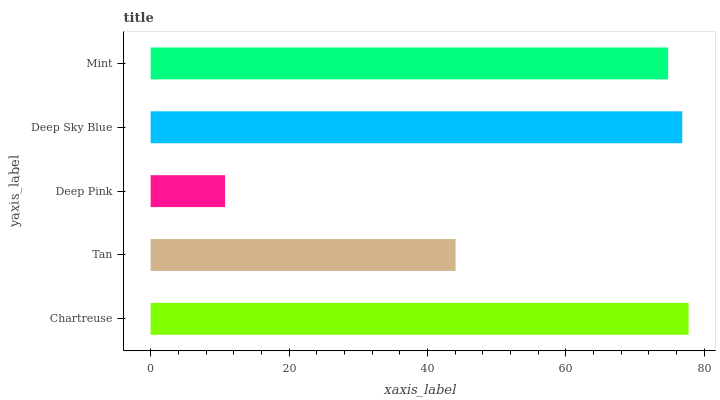Is Deep Pink the minimum?
Answer yes or no. Yes. Is Chartreuse the maximum?
Answer yes or no. Yes. Is Tan the minimum?
Answer yes or no. No. Is Tan the maximum?
Answer yes or no. No. Is Chartreuse greater than Tan?
Answer yes or no. Yes. Is Tan less than Chartreuse?
Answer yes or no. Yes. Is Tan greater than Chartreuse?
Answer yes or no. No. Is Chartreuse less than Tan?
Answer yes or no. No. Is Mint the high median?
Answer yes or no. Yes. Is Mint the low median?
Answer yes or no. Yes. Is Deep Sky Blue the high median?
Answer yes or no. No. Is Chartreuse the low median?
Answer yes or no. No. 